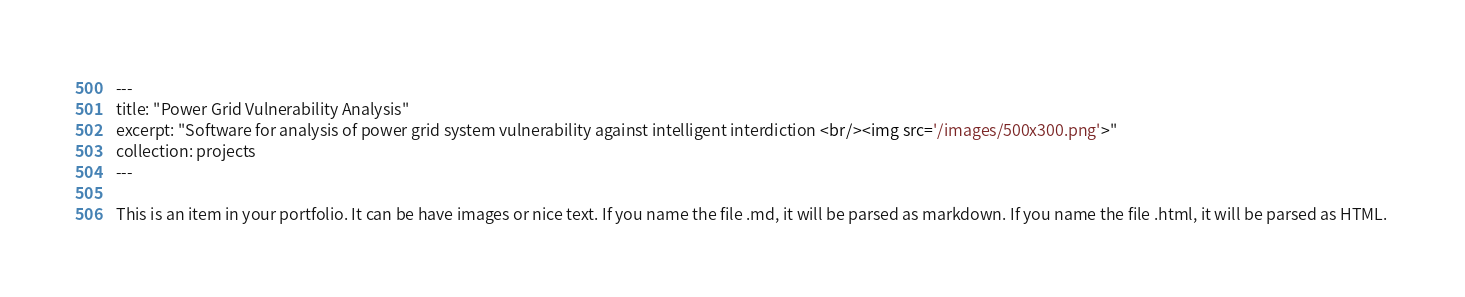Convert code to text. <code><loc_0><loc_0><loc_500><loc_500><_HTML_>---
title: "Power Grid Vulnerability Analysis"
excerpt: "Software for analysis of power grid system vulnerability against intelligent interdiction <br/><img src='/images/500x300.png'>"
collection: projects
---

This is an item in your portfolio. It can be have images or nice text. If you name the file .md, it will be parsed as markdown. If you name the file .html, it will be parsed as HTML. 
</code> 